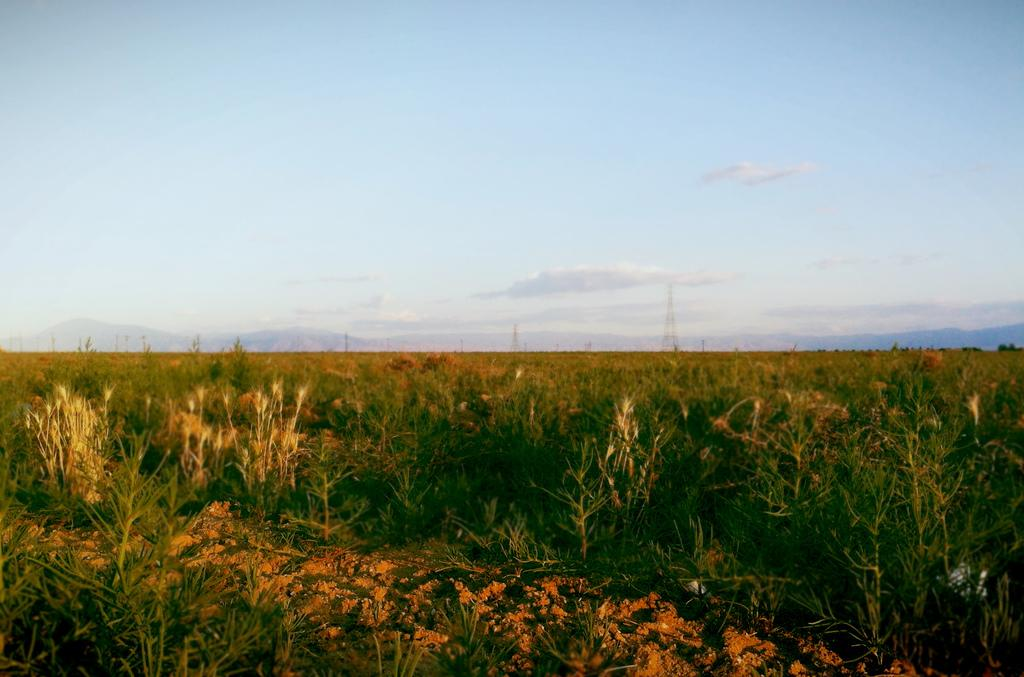What can be seen in the middle of the image? There is a path in the image. What type of vegetation is present alongside the path? There are plants on both sides of the path. What structures can be seen in the background of the image? There are towers in the background of the image. What type of natural landscape is visible in the background? There are mountains in the background of the image. What is the color of the sky in the background of the image? The sky in the background of the image is blue, and there are clouds visible. Can you tell me how many heads of lettuce are growing on the plants alongside the path? There is no lettuce present in the image; the plants are not specified. Is there a baby visible in the image? There is no baby present in the image. Are there any monkeys visible in the image? There are no monkeys present in the image. 